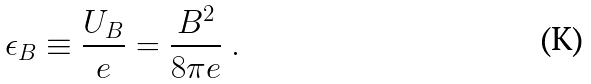Convert formula to latex. <formula><loc_0><loc_0><loc_500><loc_500>\epsilon _ { B } \equiv \frac { U _ { B } } { e } = { \frac { B ^ { 2 } } { 8 \pi e } } \ .</formula> 